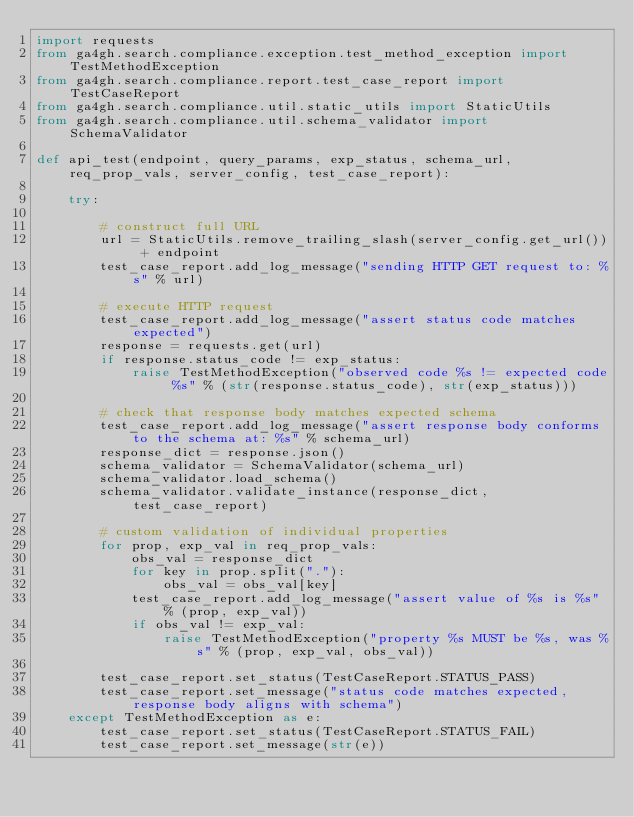<code> <loc_0><loc_0><loc_500><loc_500><_Python_>import requests
from ga4gh.search.compliance.exception.test_method_exception import TestMethodException
from ga4gh.search.compliance.report.test_case_report import TestCaseReport
from ga4gh.search.compliance.util.static_utils import StaticUtils
from ga4gh.search.compliance.util.schema_validator import SchemaValidator

def api_test(endpoint, query_params, exp_status, schema_url, req_prop_vals, server_config, test_case_report):

    try:

        # construct full URL
        url = StaticUtils.remove_trailing_slash(server_config.get_url()) + endpoint
        test_case_report.add_log_message("sending HTTP GET request to: %s" % url)

        # execute HTTP request
        test_case_report.add_log_message("assert status code matches expected")
        response = requests.get(url)
        if response.status_code != exp_status:
            raise TestMethodException("observed code %s != expected code %s" % (str(response.status_code), str(exp_status)))

        # check that response body matches expected schema
        test_case_report.add_log_message("assert response body conforms to the schema at: %s" % schema_url)
        response_dict = response.json()
        schema_validator = SchemaValidator(schema_url)
        schema_validator.load_schema()
        schema_validator.validate_instance(response_dict, test_case_report)

        # custom validation of individual properties
        for prop, exp_val in req_prop_vals:
            obs_val = response_dict
            for key in prop.split("."):
                obs_val = obs_val[key]
            test_case_report.add_log_message("assert value of %s is %s" % (prop, exp_val))
            if obs_val != exp_val:
                raise TestMethodException("property %s MUST be %s, was %s" % (prop, exp_val, obs_val))

        test_case_report.set_status(TestCaseReport.STATUS_PASS)
        test_case_report.set_message("status code matches expected, response body aligns with schema")
    except TestMethodException as e:
        test_case_report.set_status(TestCaseReport.STATUS_FAIL)
        test_case_report.set_message(str(e))
</code> 